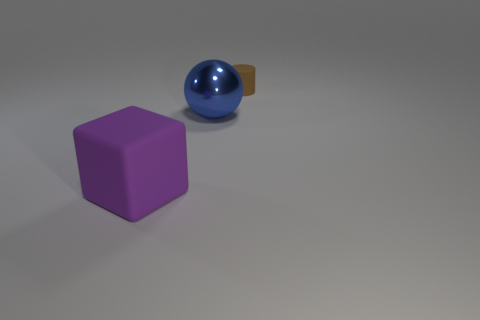Are there any other things that have the same shape as the big blue object?
Keep it short and to the point. No. What number of brown objects are large matte things or small matte things?
Give a very brief answer. 1. What number of objects are small cylinders or objects behind the large metal sphere?
Make the answer very short. 1. What is the material of the object behind the metallic thing?
Provide a short and direct response. Rubber. There is another object that is the same size as the blue shiny thing; what is its shape?
Offer a terse response. Cube. Are there any other purple things that have the same shape as the big rubber object?
Offer a terse response. No. Does the large purple cube have the same material as the large object that is behind the big rubber object?
Your answer should be very brief. No. What material is the object that is in front of the big object behind the large purple matte object made of?
Offer a very short reply. Rubber. Is the number of things that are left of the small rubber cylinder greater than the number of green metal spheres?
Provide a short and direct response. Yes. Is there a big shiny sphere?
Ensure brevity in your answer.  Yes. 